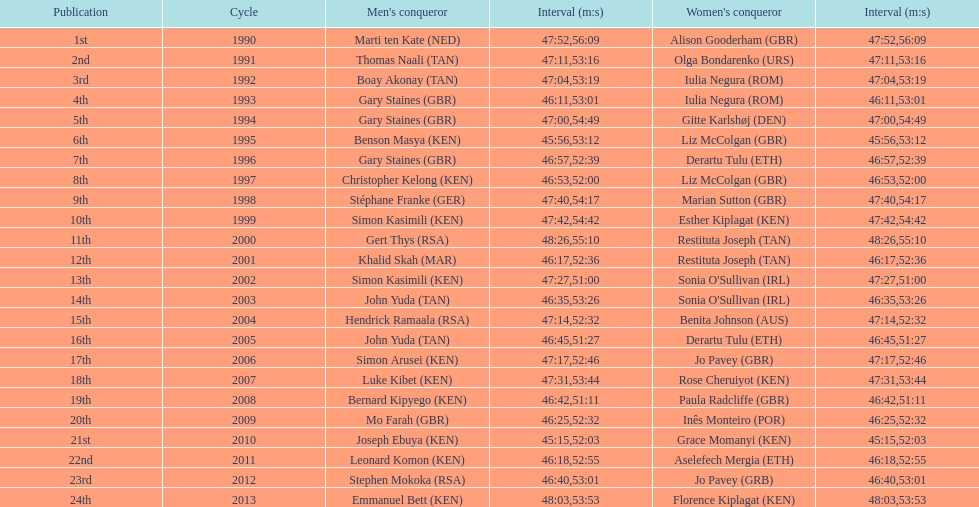Who has the fastest recorded finish for the men's bupa great south run, between 1990 and 2013? Joseph Ebuya (KEN). 